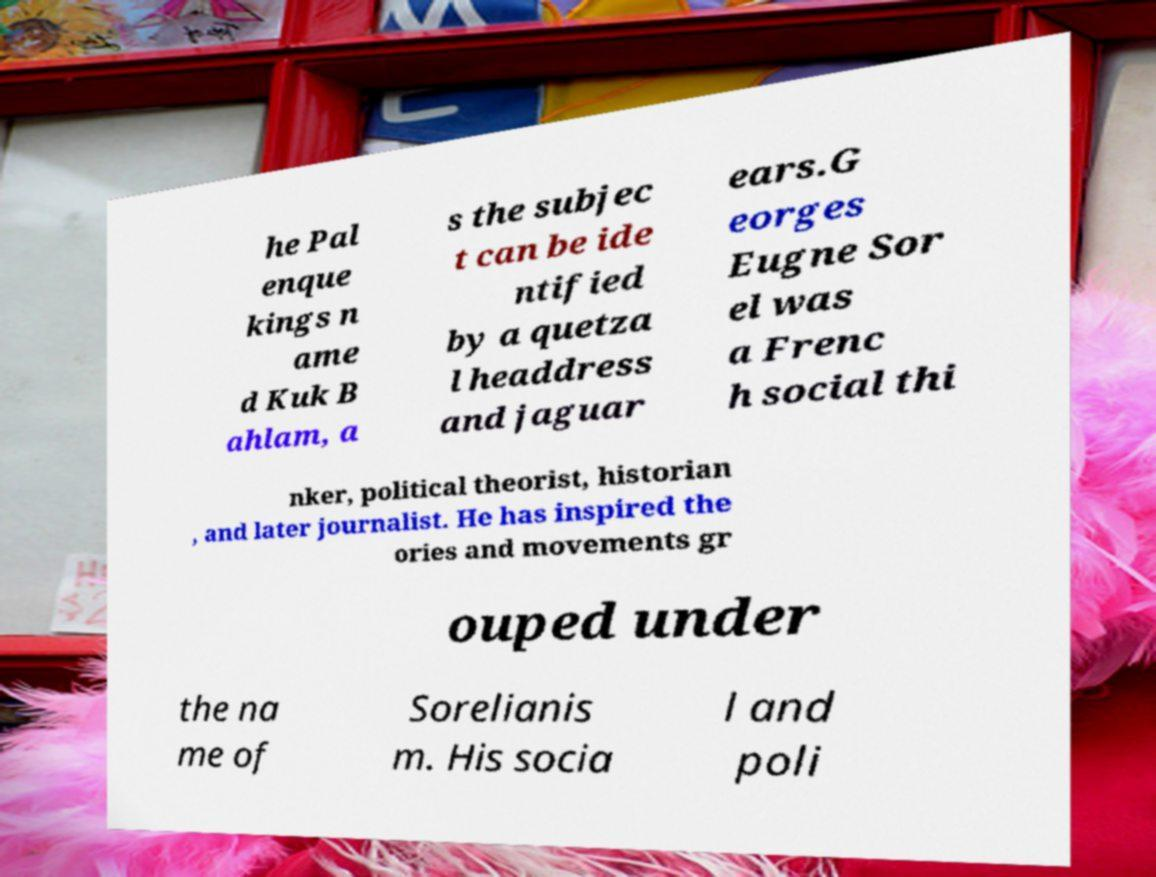What messages or text are displayed in this image? I need them in a readable, typed format. he Pal enque kings n ame d Kuk B ahlam, a s the subjec t can be ide ntified by a quetza l headdress and jaguar ears.G eorges Eugne Sor el was a Frenc h social thi nker, political theorist, historian , and later journalist. He has inspired the ories and movements gr ouped under the na me of Sorelianis m. His socia l and poli 